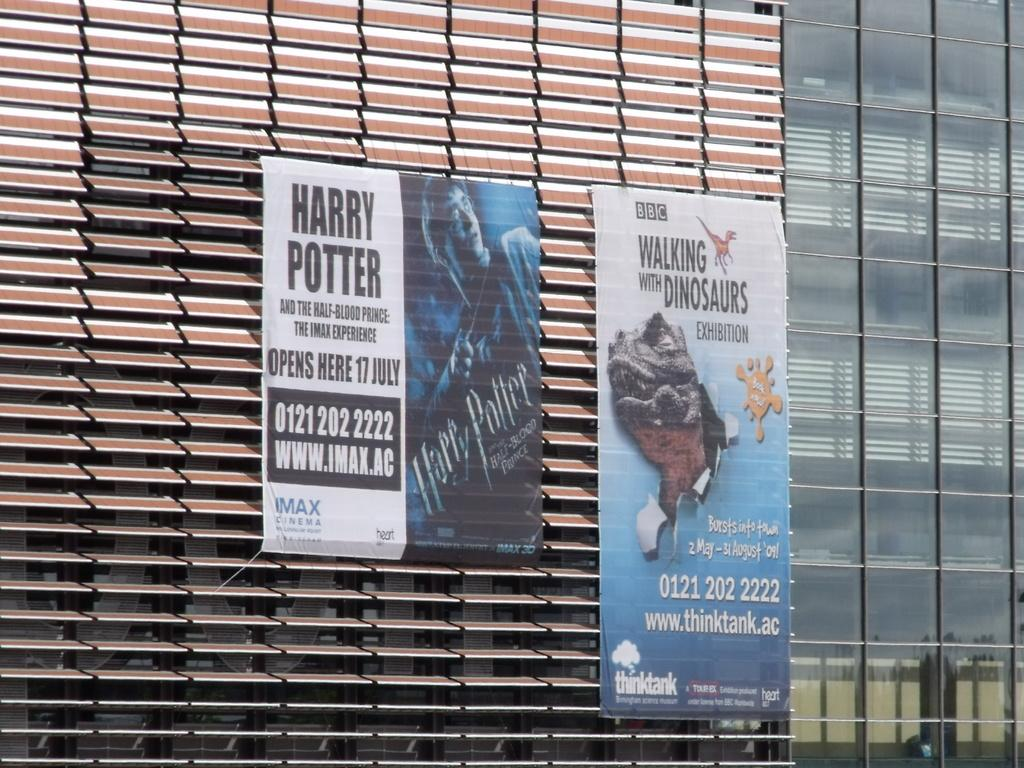<image>
Describe the image concisely. Movie posters show when Harry Potter will play on IMAX. 